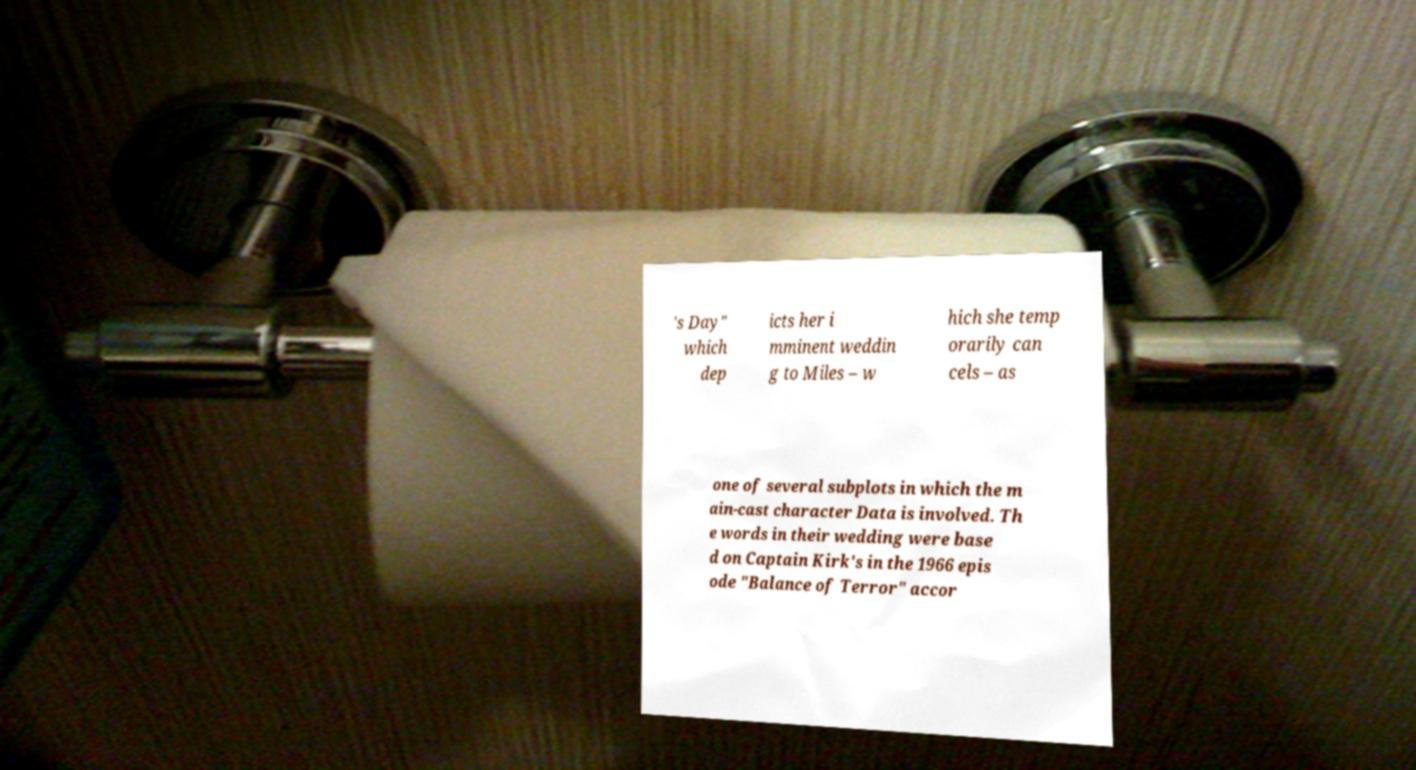Please identify and transcribe the text found in this image. 's Day" which dep icts her i mminent weddin g to Miles – w hich she temp orarily can cels – as one of several subplots in which the m ain-cast character Data is involved. Th e words in their wedding were base d on Captain Kirk's in the 1966 epis ode "Balance of Terror" accor 